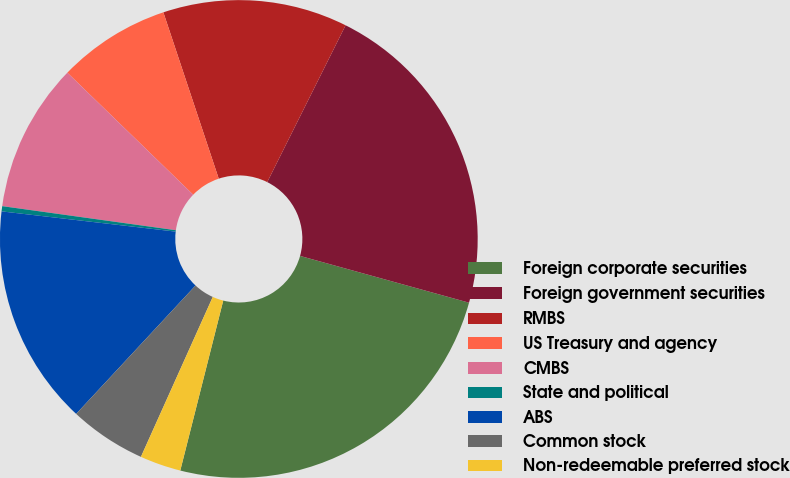<chart> <loc_0><loc_0><loc_500><loc_500><pie_chart><fcel>Foreign corporate securities<fcel>Foreign government securities<fcel>RMBS<fcel>US Treasury and agency<fcel>CMBS<fcel>State and political<fcel>ABS<fcel>Common stock<fcel>Non-redeemable preferred stock<nl><fcel>24.64%<fcel>21.92%<fcel>12.49%<fcel>7.63%<fcel>10.06%<fcel>0.35%<fcel>14.92%<fcel>5.2%<fcel>2.78%<nl></chart> 